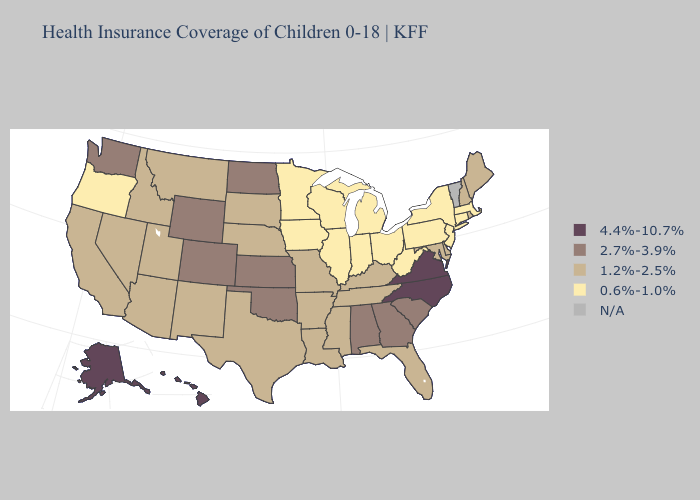Does Virginia have the highest value in the USA?
Be succinct. Yes. What is the highest value in the South ?
Concise answer only. 4.4%-10.7%. Does Nebraska have the highest value in the USA?
Concise answer only. No. What is the value of Illinois?
Answer briefly. 0.6%-1.0%. Name the states that have a value in the range N/A?
Give a very brief answer. Vermont. Name the states that have a value in the range 1.2%-2.5%?
Keep it brief. Arizona, Arkansas, California, Delaware, Florida, Idaho, Kentucky, Louisiana, Maine, Maryland, Mississippi, Missouri, Montana, Nebraska, Nevada, New Hampshire, New Mexico, Rhode Island, South Dakota, Tennessee, Texas, Utah. What is the value of Kansas?
Answer briefly. 2.7%-3.9%. What is the highest value in the Northeast ?
Write a very short answer. 1.2%-2.5%. Among the states that border Pennsylvania , does Delaware have the lowest value?
Keep it brief. No. What is the highest value in states that border Indiana?
Write a very short answer. 1.2%-2.5%. What is the value of Arizona?
Be succinct. 1.2%-2.5%. Does the first symbol in the legend represent the smallest category?
Keep it brief. No. Among the states that border Missouri , does Kansas have the highest value?
Short answer required. Yes. What is the value of Ohio?
Concise answer only. 0.6%-1.0%. Does Alaska have the lowest value in the USA?
Keep it brief. No. 